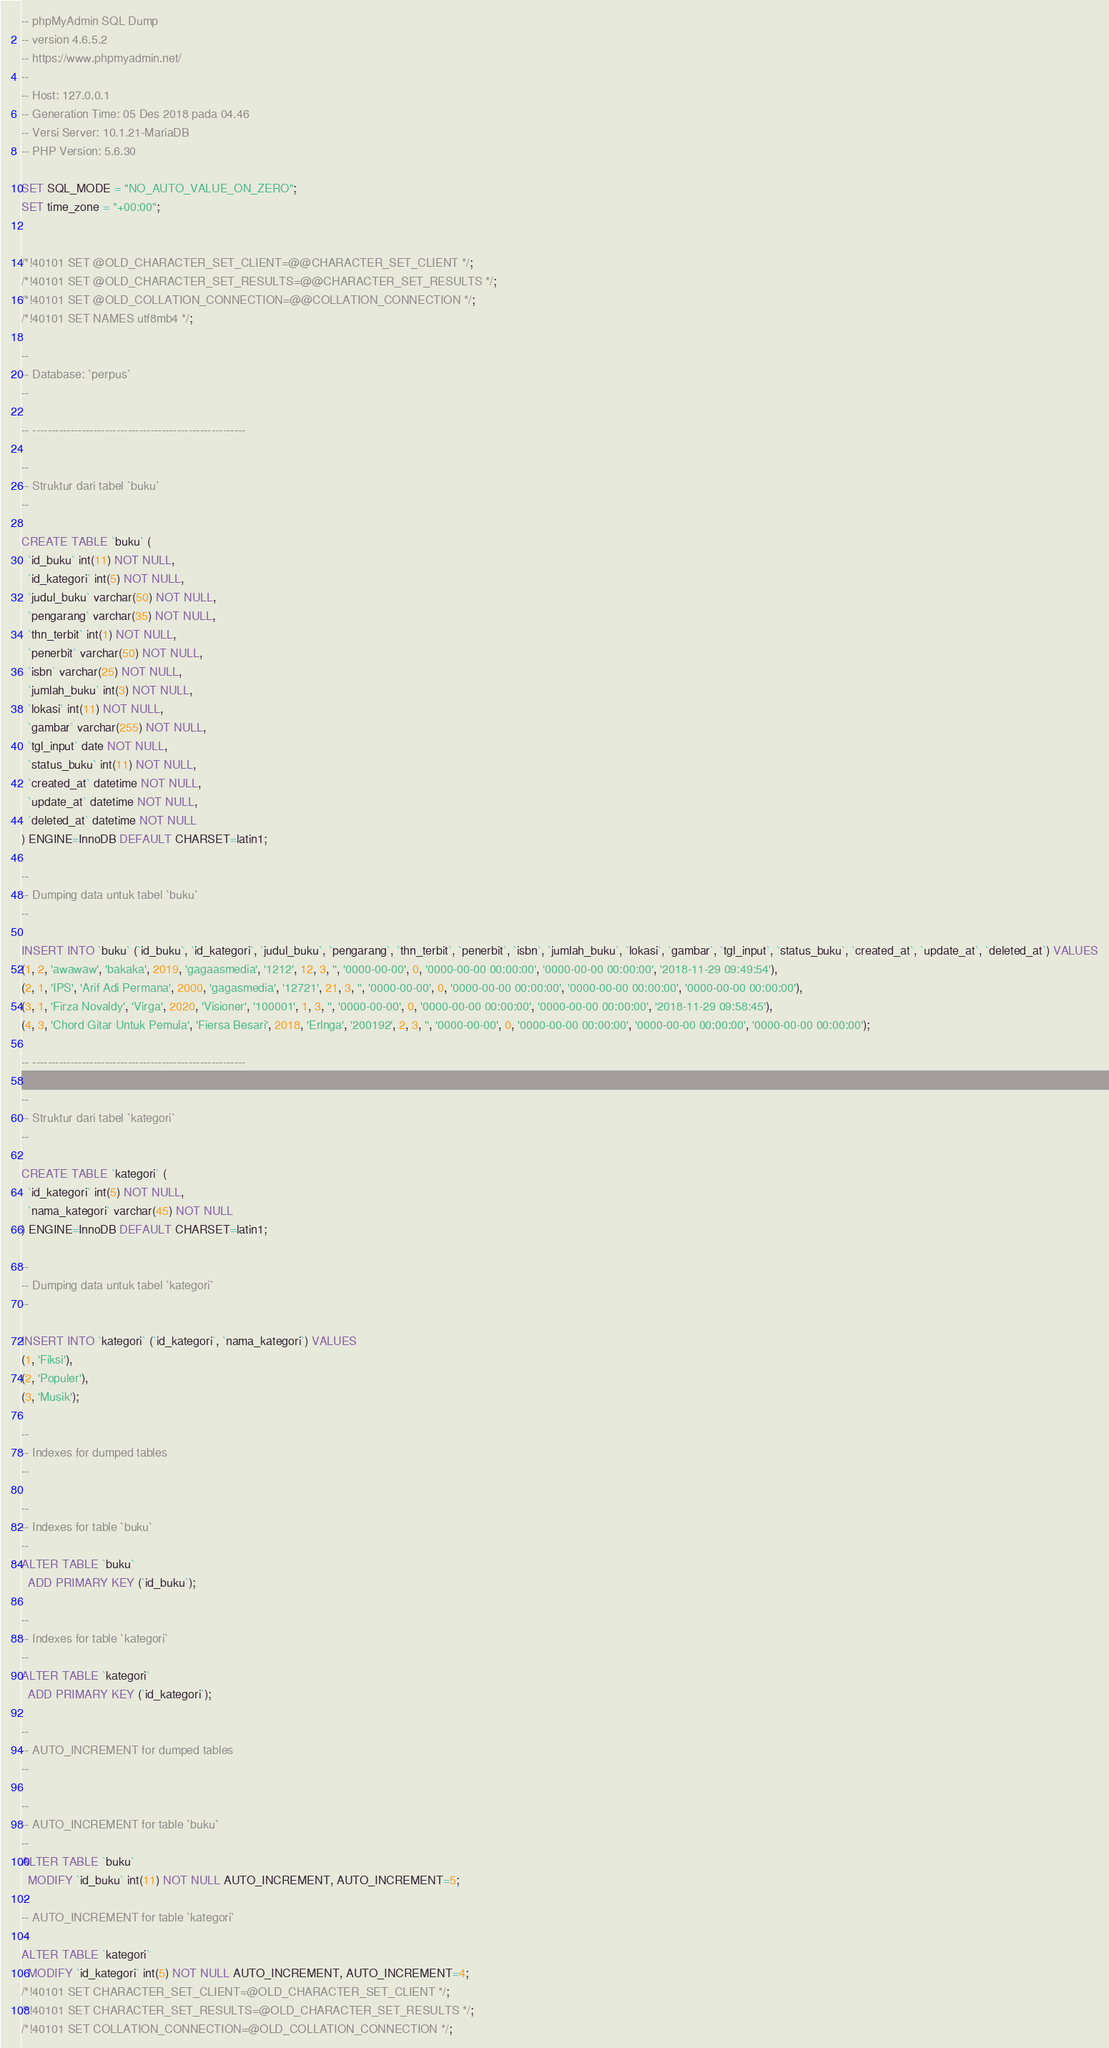<code> <loc_0><loc_0><loc_500><loc_500><_SQL_>-- phpMyAdmin SQL Dump
-- version 4.6.5.2
-- https://www.phpmyadmin.net/
--
-- Host: 127.0.0.1
-- Generation Time: 05 Des 2018 pada 04.46
-- Versi Server: 10.1.21-MariaDB
-- PHP Version: 5.6.30

SET SQL_MODE = "NO_AUTO_VALUE_ON_ZERO";
SET time_zone = "+00:00";


/*!40101 SET @OLD_CHARACTER_SET_CLIENT=@@CHARACTER_SET_CLIENT */;
/*!40101 SET @OLD_CHARACTER_SET_RESULTS=@@CHARACTER_SET_RESULTS */;
/*!40101 SET @OLD_COLLATION_CONNECTION=@@COLLATION_CONNECTION */;
/*!40101 SET NAMES utf8mb4 */;

--
-- Database: `perpus`
--

-- --------------------------------------------------------

--
-- Struktur dari tabel `buku`
--

CREATE TABLE `buku` (
  `id_buku` int(11) NOT NULL,
  `id_kategori` int(5) NOT NULL,
  `judul_buku` varchar(50) NOT NULL,
  `pengarang` varchar(35) NOT NULL,
  `thn_terbit` int(1) NOT NULL,
  `penerbit` varchar(50) NOT NULL,
  `isbn` varchar(25) NOT NULL,
  `jumlah_buku` int(3) NOT NULL,
  `lokasi` int(11) NOT NULL,
  `gambar` varchar(255) NOT NULL,
  `tgl_input` date NOT NULL,
  `status_buku` int(11) NOT NULL,
  `created_at` datetime NOT NULL,
  `update_at` datetime NOT NULL,
  `deleted_at` datetime NOT NULL
) ENGINE=InnoDB DEFAULT CHARSET=latin1;

--
-- Dumping data untuk tabel `buku`
--

INSERT INTO `buku` (`id_buku`, `id_kategori`, `judul_buku`, `pengarang`, `thn_terbit`, `penerbit`, `isbn`, `jumlah_buku`, `lokasi`, `gambar`, `tgl_input`, `status_buku`, `created_at`, `update_at`, `deleted_at`) VALUES
(1, 2, 'awawaw', 'bakaka', 2019, 'gagaasmedia', '1212', 12, 3, '', '0000-00-00', 0, '0000-00-00 00:00:00', '0000-00-00 00:00:00', '2018-11-29 09:49:54'),
(2, 1, 'IPS', 'Arif Adi Permana', 2000, 'gagasmedia', '12721', 21, 3, '', '0000-00-00', 0, '0000-00-00 00:00:00', '0000-00-00 00:00:00', '0000-00-00 00:00:00'),
(3, 1, 'Firza Novaldy', 'Virga', 2020, 'Visioner', '100001', 1, 3, '', '0000-00-00', 0, '0000-00-00 00:00:00', '0000-00-00 00:00:00', '2018-11-29 09:58:45'),
(4, 3, 'Chord Gitar Untuk Pemula', 'Fiersa Besari', 2018, 'Erlnga', '200192', 2, 3, '', '0000-00-00', 0, '0000-00-00 00:00:00', '0000-00-00 00:00:00', '0000-00-00 00:00:00');

-- --------------------------------------------------------

--
-- Struktur dari tabel `kategori`
--

CREATE TABLE `kategori` (
  `id_kategori` int(5) NOT NULL,
  `nama_kategori` varchar(45) NOT NULL
) ENGINE=InnoDB DEFAULT CHARSET=latin1;

--
-- Dumping data untuk tabel `kategori`
--

INSERT INTO `kategori` (`id_kategori`, `nama_kategori`) VALUES
(1, 'Fiksi'),
(2, 'Populer'),
(3, 'Musik');

--
-- Indexes for dumped tables
--

--
-- Indexes for table `buku`
--
ALTER TABLE `buku`
  ADD PRIMARY KEY (`id_buku`);

--
-- Indexes for table `kategori`
--
ALTER TABLE `kategori`
  ADD PRIMARY KEY (`id_kategori`);

--
-- AUTO_INCREMENT for dumped tables
--

--
-- AUTO_INCREMENT for table `buku`
--
ALTER TABLE `buku`
  MODIFY `id_buku` int(11) NOT NULL AUTO_INCREMENT, AUTO_INCREMENT=5;
--
-- AUTO_INCREMENT for table `kategori`
--
ALTER TABLE `kategori`
  MODIFY `id_kategori` int(5) NOT NULL AUTO_INCREMENT, AUTO_INCREMENT=4;
/*!40101 SET CHARACTER_SET_CLIENT=@OLD_CHARACTER_SET_CLIENT */;
/*!40101 SET CHARACTER_SET_RESULTS=@OLD_CHARACTER_SET_RESULTS */;
/*!40101 SET COLLATION_CONNECTION=@OLD_COLLATION_CONNECTION */;
</code> 